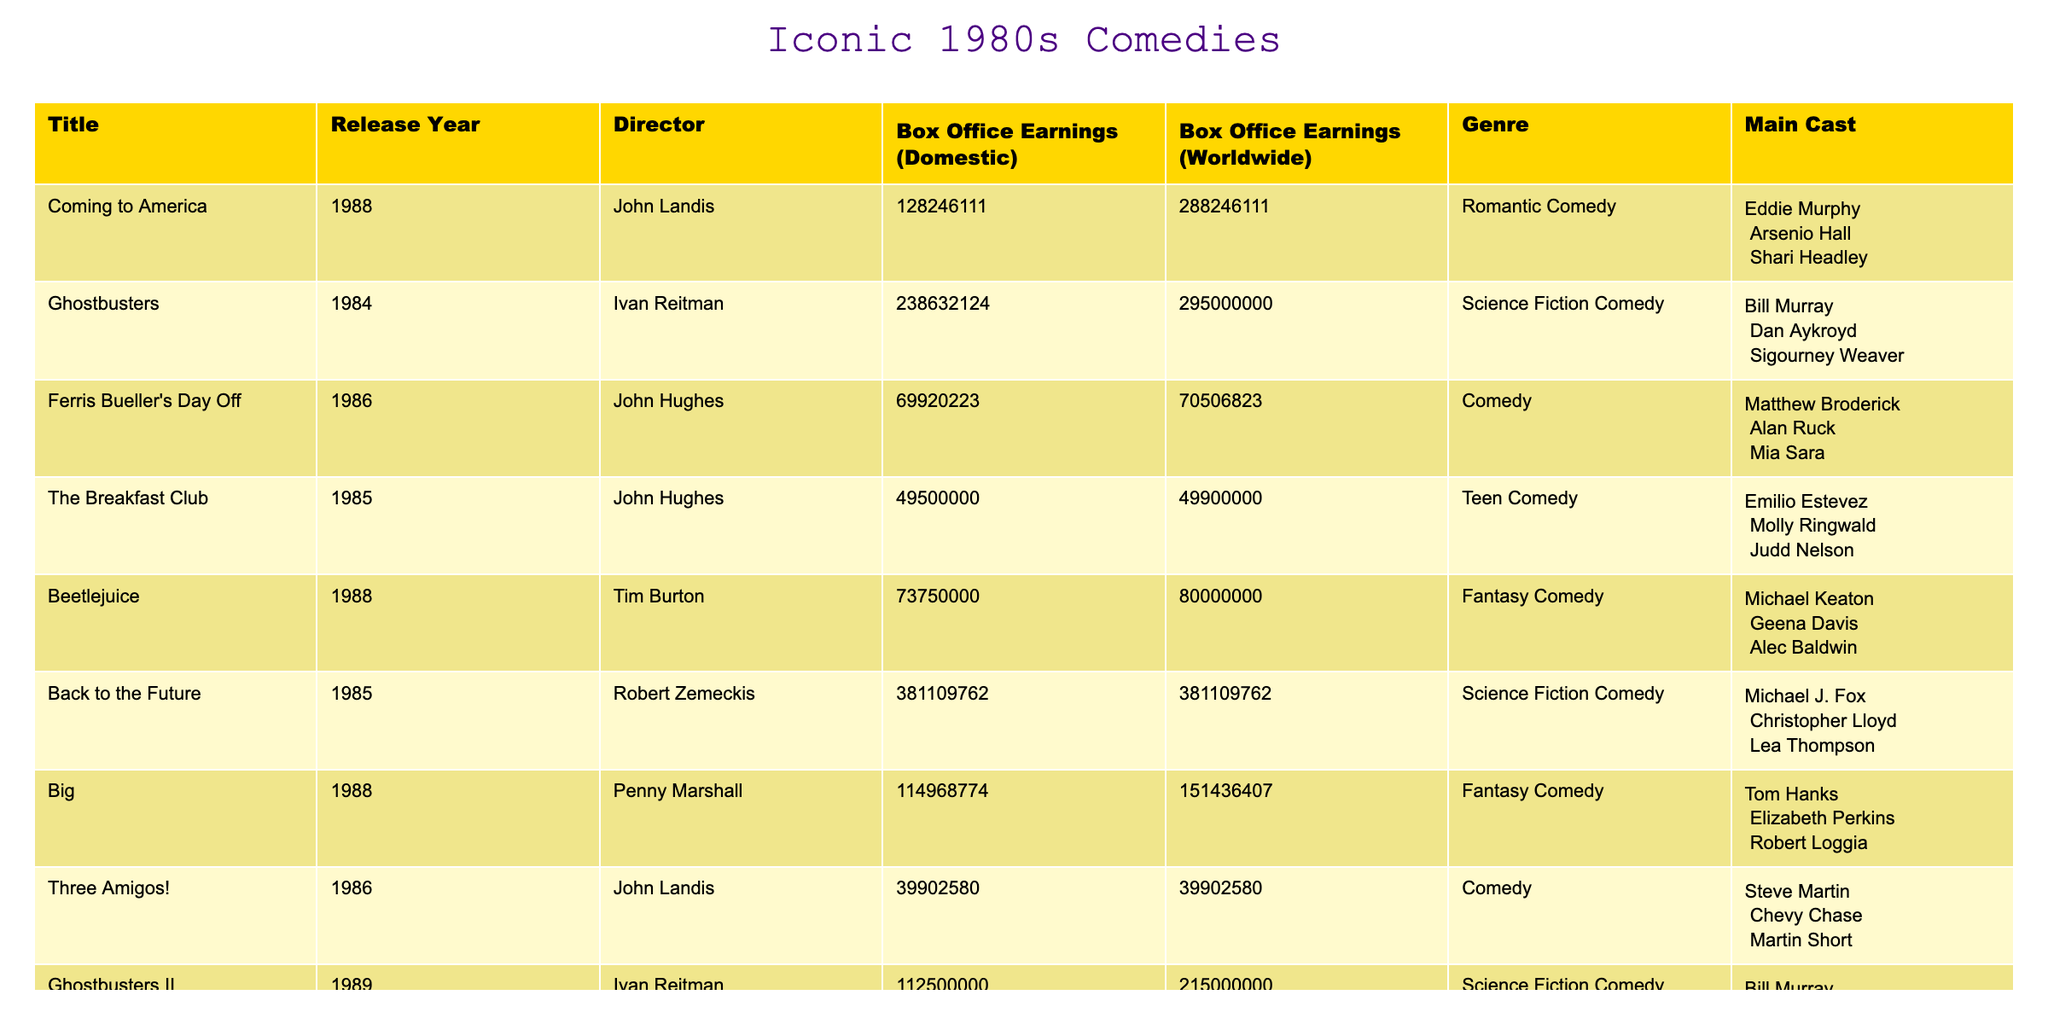What is the box office earnings for "Coming to America"? The table shows the box office earnings for "Coming to America" as $128,246,111 (domestic) and $288,246,111 (worldwide).
Answer: $128,246,111 (domestic), $288,246,111 (worldwide) Which film had the highest worldwide box office earnings? By comparing the worldwide box office earnings figures, "Ghostbusters" has the highest earnings at $295,000,000.
Answer: "Ghostbusters" How much did "Back to the Future" earn domestically compared to "Ferris Bueller's Day Off"? "Back to the Future" earned $381,109,762 domestically, whereas "Ferris Bueller's Day Off" earned $69,920,223. This indicates a difference of $311,189,539, with "Back to the Future" earning significantly more.
Answer: $311,189,539 What is the total box office earnings for all movies listed in the table? Adding all the domestic box office earnings: $128,246,111 + $238,632,124 + $69,920,223 + $49,500,000 + $73,750,000 + $381,109,762 + $114,968,774 + $39,902,580 + $112,500,000 = $1,028,087,074.
Answer: $1,028,087,074 Is "Big" a romantic comedy? The genre listed for "Big" in the table is Fantasy Comedy, which confirms that it is not a romantic comedy.
Answer: No How much more did "Beetlejuice" earn worldwide compared to its domestic total? "Beetlejuice" earned $73,750,000 domestically and $80,000,000 worldwide. The difference is $80,000,000 - $73,750,000 = $6,250,000.
Answer: $6,250,000 What percentage of the total box office earnings does "The Breakfast Club" represent? "The Breakfast Club" earned $49,500,000. To find its percentage: ($49,500,000 / $1,028,087,074) * 100 = approximately 4.82%.
Answer: 4.82% Which director has the most films listed in the table? John Hughes directed two movies: "Ferris Bueller's Day Off" and "The Breakfast Club," making him the director with the most films in this list.
Answer: John Hughes What is the average domestic box office earnings for the films directed by John Landis? John Landis directed "Coming to America" and "Three Amigos!" with domestic earnings of $128,246,111 and $39,902,580, respectively. The average is calculated as: ($128,246,111 + $39,902,580) / 2 = $84,074,345.5.
Answer: $84,074,345.5 Which film features Eddie Murphy in the main cast? The table lists "Coming to America" as featuring Eddie Murphy in the main cast.
Answer: "Coming to America" 